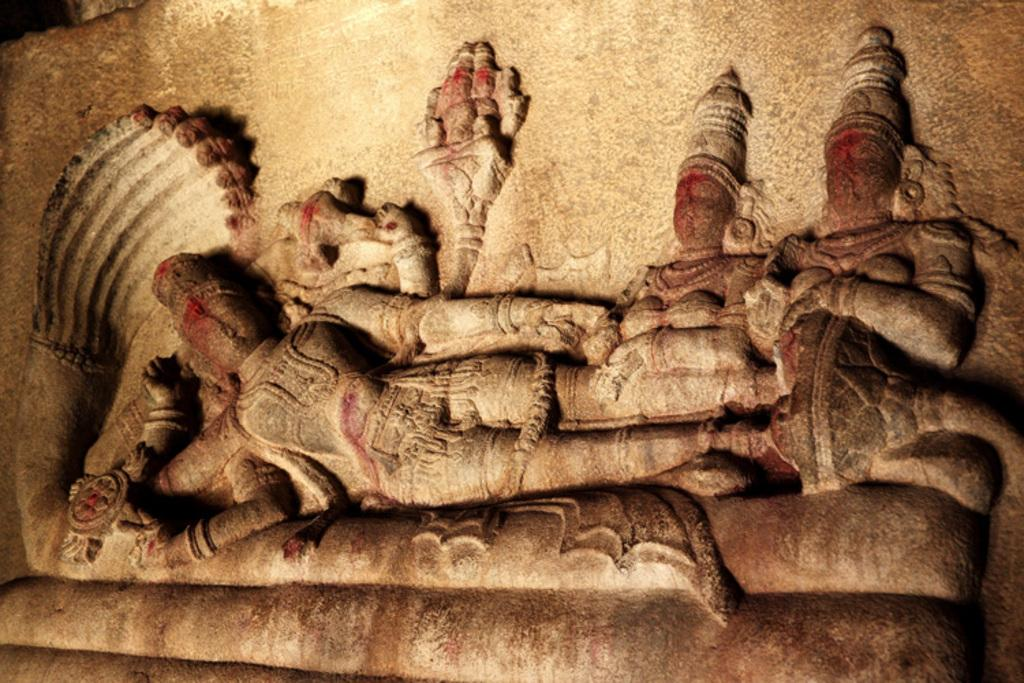What is on the rock in the image? There are sculptures on the rock in the image. What is the person on the left side of the image doing? The person is lying on a snake in the image. Where are the two persons in the image located? The two persons are sitting on the right side of the image. How many giants can be seen in the image? There are no giants present in the image. What type of quill is the person using to draw the sculptures? There is no quill visible in the image, and the person is not drawing the sculptures. 